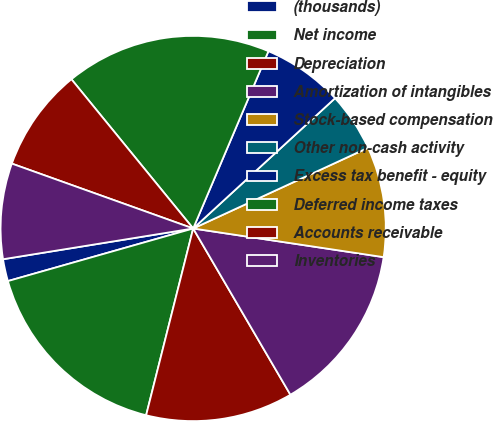Convert chart to OTSL. <chart><loc_0><loc_0><loc_500><loc_500><pie_chart><fcel>(thousands)<fcel>Net income<fcel>Depreciation<fcel>Amortization of intangibles<fcel>Stock-based compensation<fcel>Other non-cash activity<fcel>Excess tax benefit - equity<fcel>Deferred income taxes<fcel>Accounts receivable<fcel>Inventories<nl><fcel>1.85%<fcel>16.67%<fcel>12.35%<fcel>14.2%<fcel>9.26%<fcel>4.94%<fcel>6.79%<fcel>17.28%<fcel>8.64%<fcel>8.02%<nl></chart> 